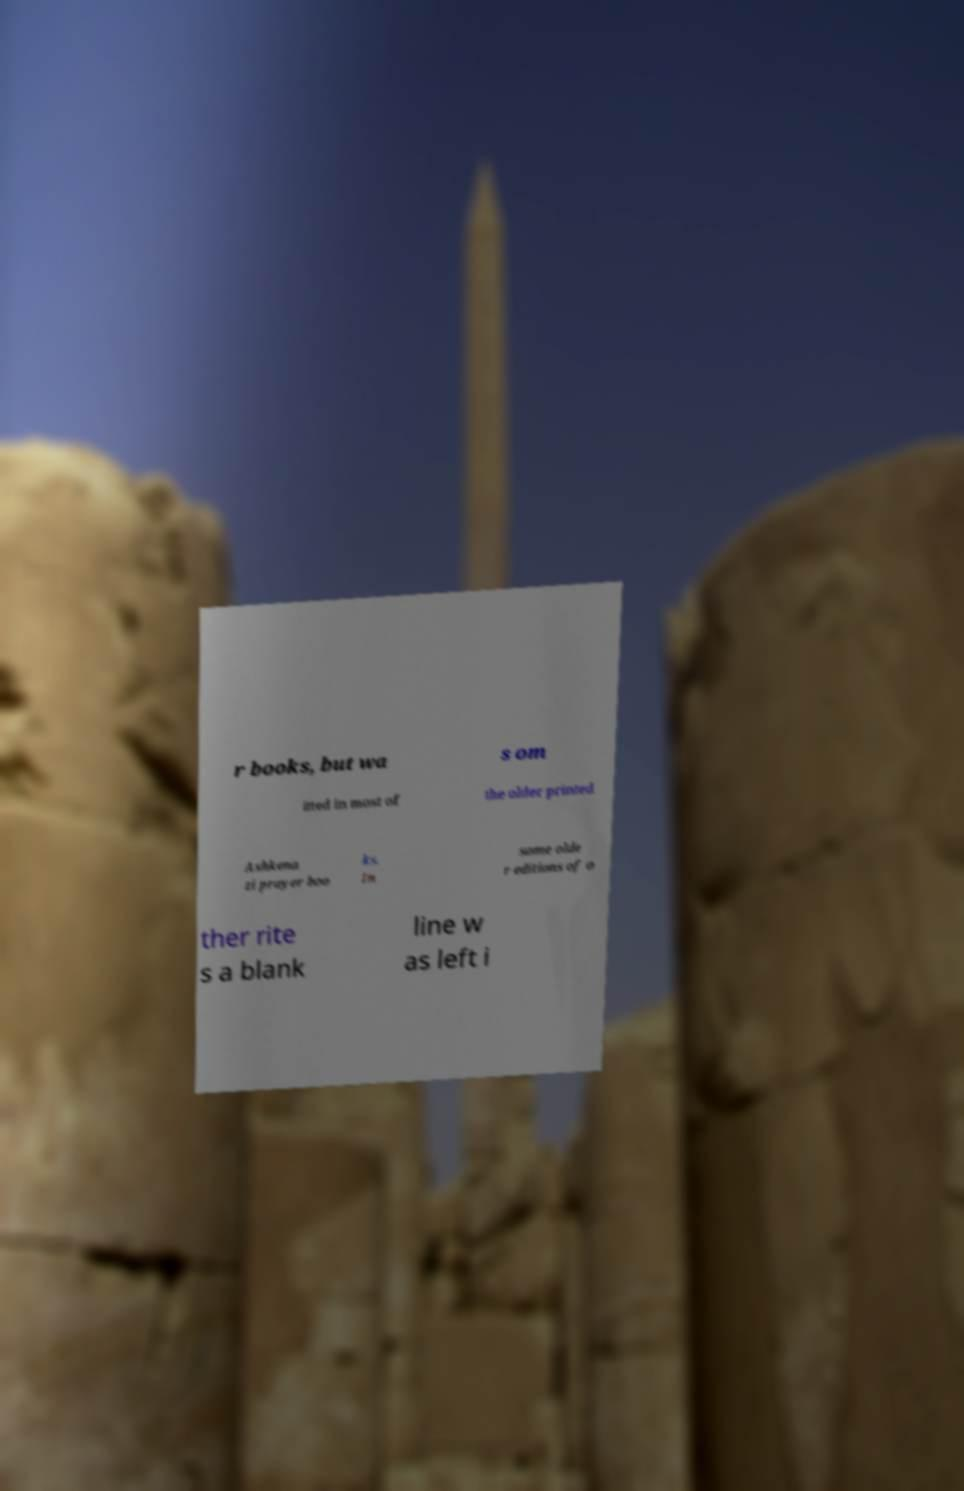Can you accurately transcribe the text from the provided image for me? r books, but wa s om itted in most of the older printed Ashkena zi prayer boo ks. In some olde r editions of o ther rite s a blank line w as left i 